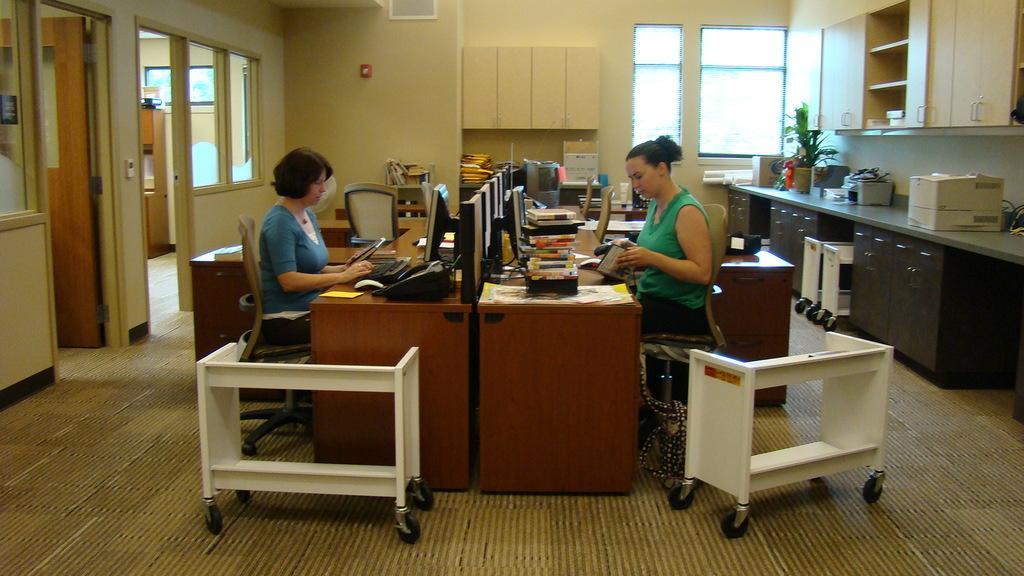How would you summarize this image in a sentence or two? There are two women sitting on chair on opposite direction of each other. 